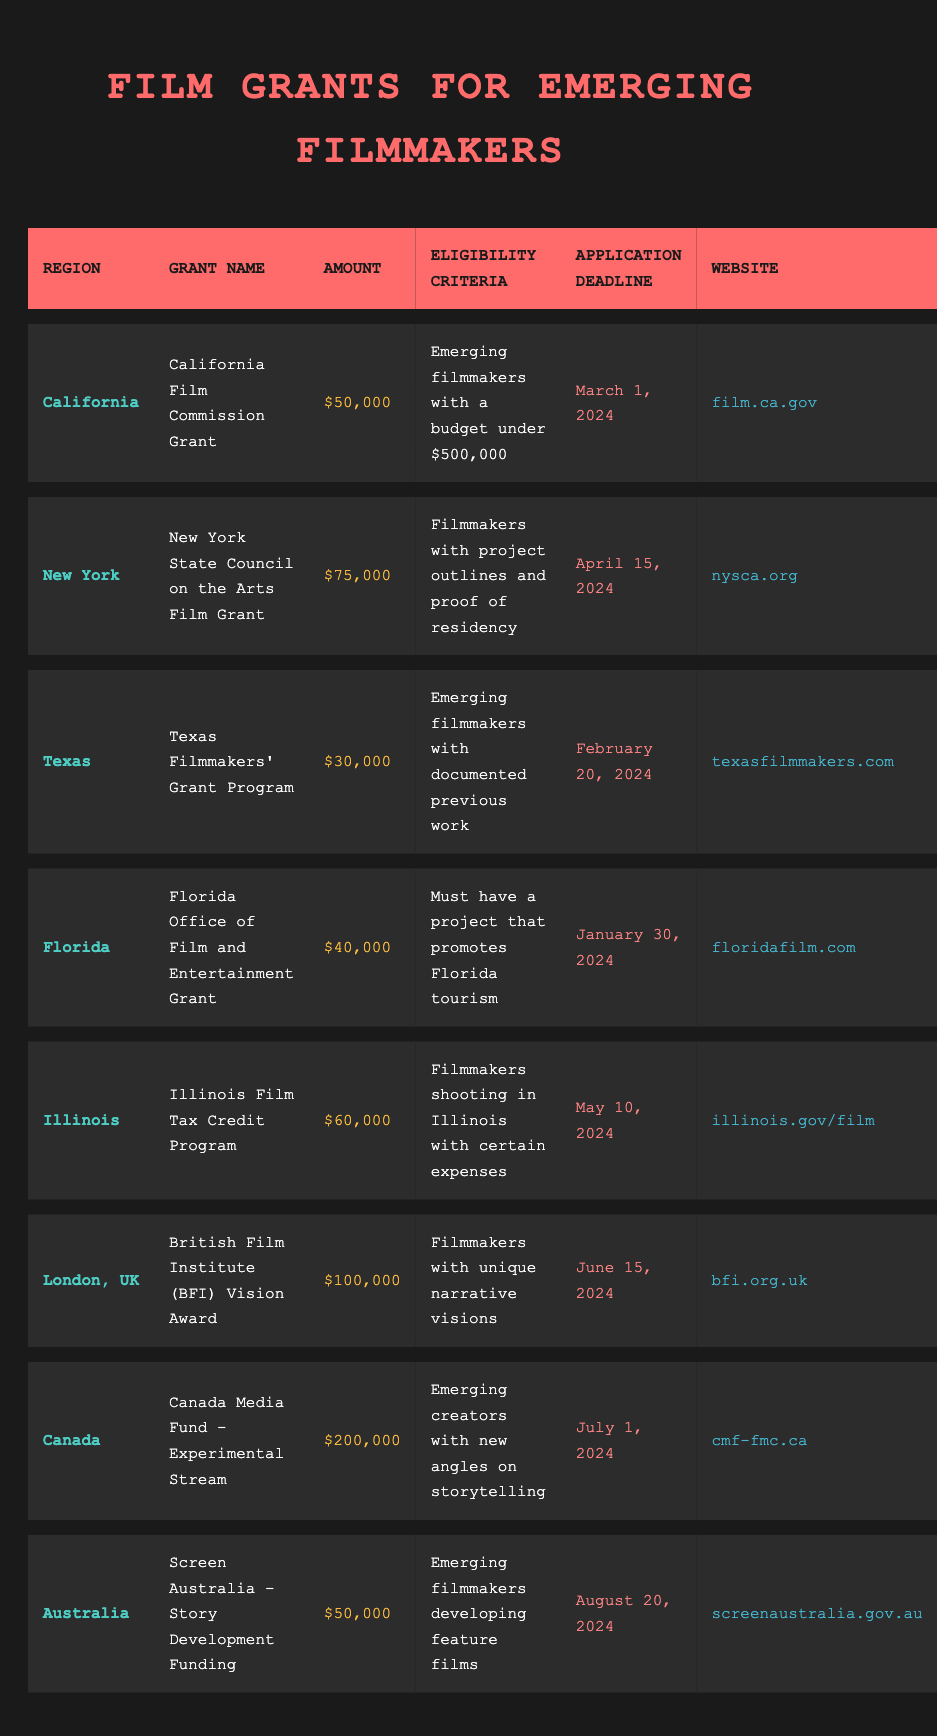What is the grant amount for the Texas Filmmakers' Grant Program? The Texas Filmmakers' Grant Program is listed in the table with an amount of $30,000.
Answer: $30,000 Which grant has the highest amount available? In the table, the Canada Media Fund - Experimental Stream has the highest amount listed at $200,000, which is greater than all other grants.
Answer: $200,000 Are filmmakers eligible for the Florida grant if their project does not promote Florida tourism? The eligibility criteria for the Florida grant specifically states that projects must promote Florida tourism, so if it does not, the filmmakers would not be eligible.
Answer: No What is the application deadline for the New York State Council on the Arts Film Grant? The application deadline is explicitly stated in the table as April 15, 2024.
Answer: April 15, 2024 Calculate the average grant amount for all listed grants. The total grant amounts are $50,000 + $75,000 + $30,000 + $40,000 + $60,000 + $100,000 + $200,000 + $50,000 = $605,000. There are 8 grants listed, so the average is $605,000 / 8 = $75,625.
Answer: $75,625 Is there a grant available for filmmakers in Australia? The table shows that there is indeed a grant available in Australia, specifically the "Screen Australia - Story Development Funding" grant.
Answer: Yes How many grants require applicants to have previous work documented? According to the table, only the "Texas Filmmakers' Grant Program" requires applicants to have documented previous work, indicating that there is just one grant with this prerequisite.
Answer: 1 What is the eligibility criterion for the British Film Institute's Vision Award? The eligibility criterion is stated in the table as filmmakers must have unique narrative visions to qualify for the British Film Institute's Vision Award.
Answer: Unique narrative visions Which regions have grants with application deadlines in the first half of 2024? The deadlines in the first half of 2024 are for the Florida grant (January 30), Texas grant (February 20), California grant (March 1), and New York grant (April 15), totaling four regions.
Answer: 4 